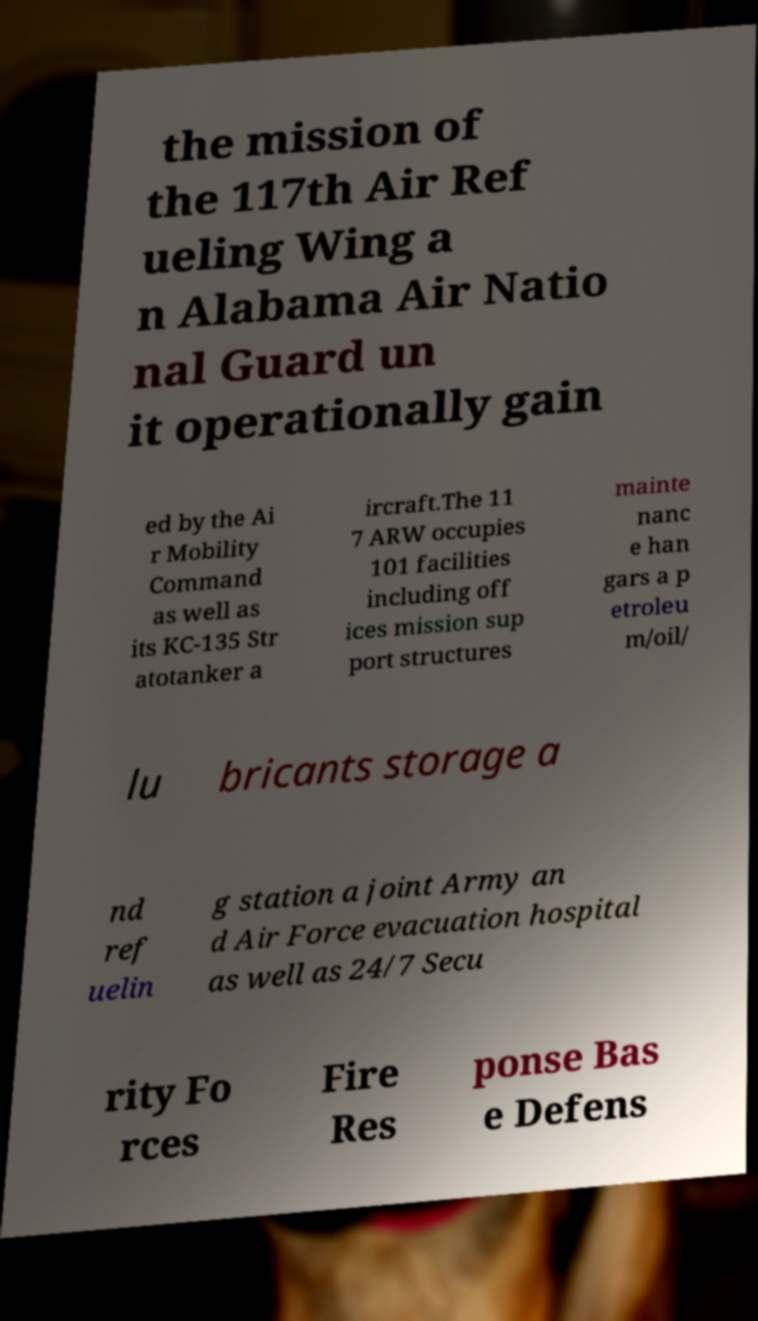I need the written content from this picture converted into text. Can you do that? the mission of the 117th Air Ref ueling Wing a n Alabama Air Natio nal Guard un it operationally gain ed by the Ai r Mobility Command as well as its KC-135 Str atotanker a ircraft.The 11 7 ARW occupies 101 facilities including off ices mission sup port structures mainte nanc e han gars a p etroleu m/oil/ lu bricants storage a nd ref uelin g station a joint Army an d Air Force evacuation hospital as well as 24/7 Secu rity Fo rces Fire Res ponse Bas e Defens 